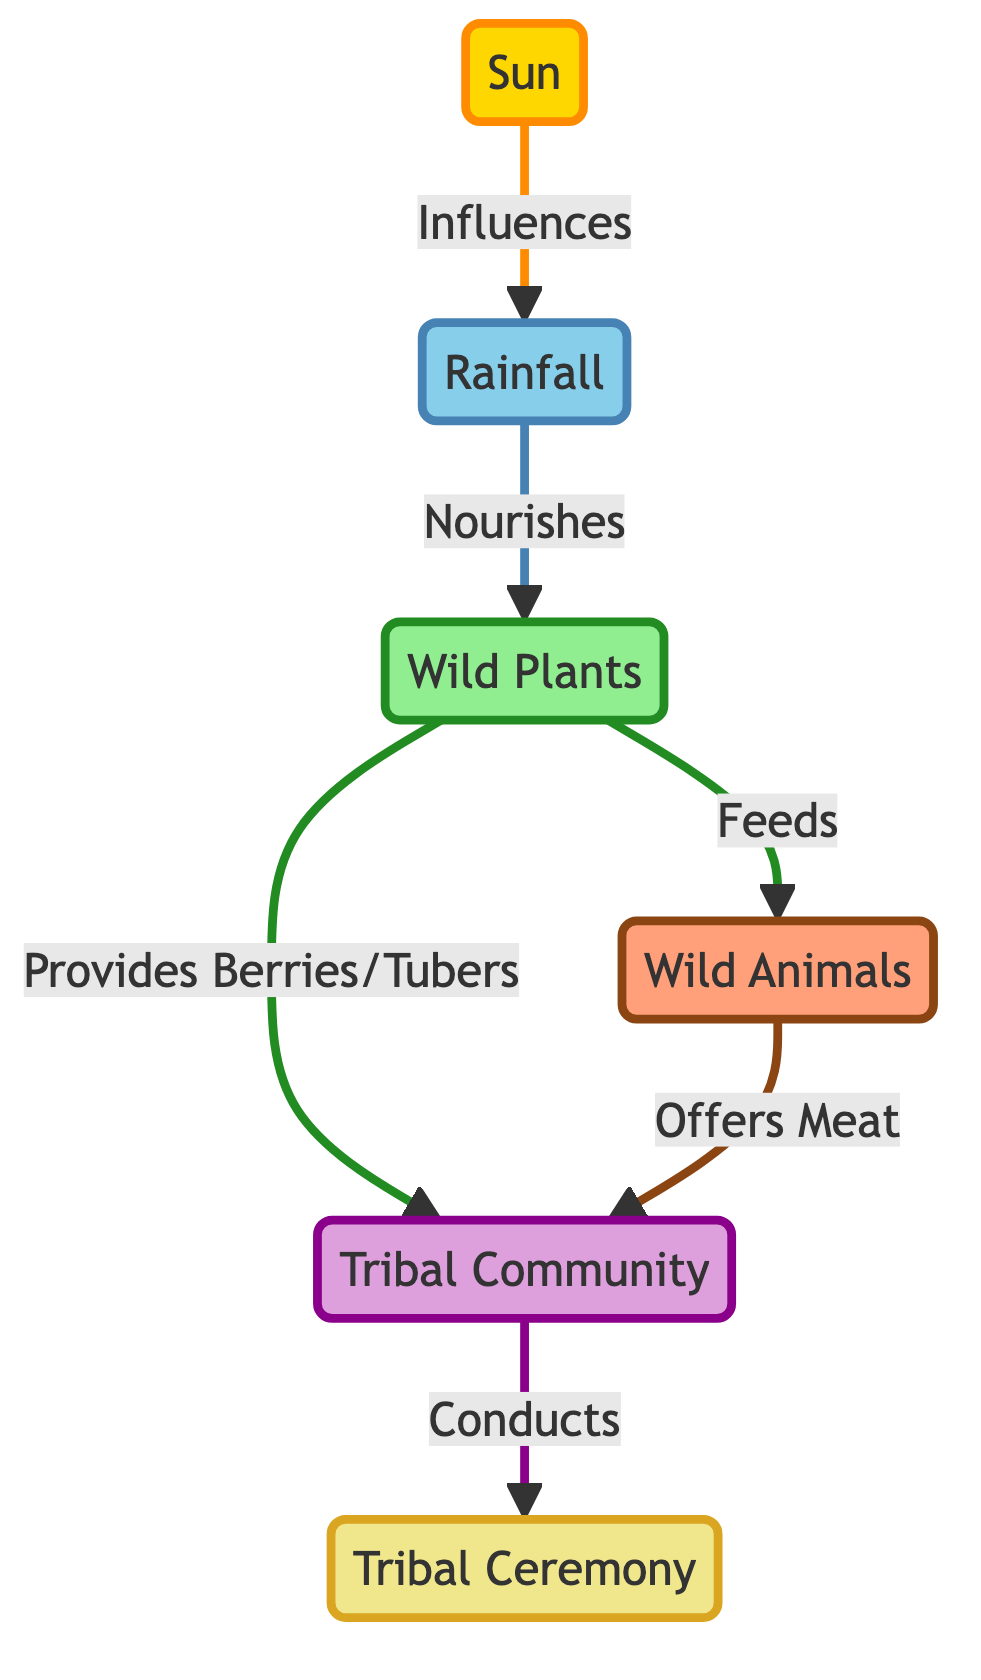What's the primary source influencing rainfall? The diagram shows that "Sun" influences "Rainfall." This indicates that sunlight plays a critical role in the evaporation and condensation processes that lead to rain.
Answer: Sun How many main elements are in this food chain? By counting the distinct nodes in the diagram, we find that there are six main elements: Sun, Rainfall, Wild Plants, Wild Animals, Tribal Community, and Tribal Ceremony.
Answer: 6 What do wild plants provide to the tribe? The diagram illustrates that wild plants provide berries and tubers to the tribal community, which are essential for their sustenance.
Answer: Berries/Tubers Which element feeds animals in the food chain? According to the diagram, "Plants" feed "Animals," suggesting that the animals rely on wild plants for their nourishment.
Answer: Plants What do animals offer to the tribe? The diagram indicates that "Animals" offers "Meat" to the tribe, highlighting the role of wildlife in providing food resources for the community.
Answer: Meat How does rainfall affect plants? The diagram specifies that "Rainfall" nourishes "Plants," indicating that adequate precipitation is essential for plant growth and development.
Answer: Nourishes What is the final outcome of the process initiated by the sun? Following the flow from the "Sun" to "Rainfall," then to "Plants," and subsequently to the "Tribal Community" conducting the "Ceremony," we see that the final outcome is the "Tribal Ceremony."
Answer: Tribal Ceremony What relationship exists between plants and animals in this food chain? The diagram shows that "Plants" feeds "Animals," which establishes a direct relationship where plants serve as a food source for animals.
Answer: Feeds What role does the tribal community play in relation to the ceremony? The diagram depicts that the "Tribal Community" conducts the "Tribal Ceremony," pointing to their active participation in this cultural event.
Answer: Conducts 